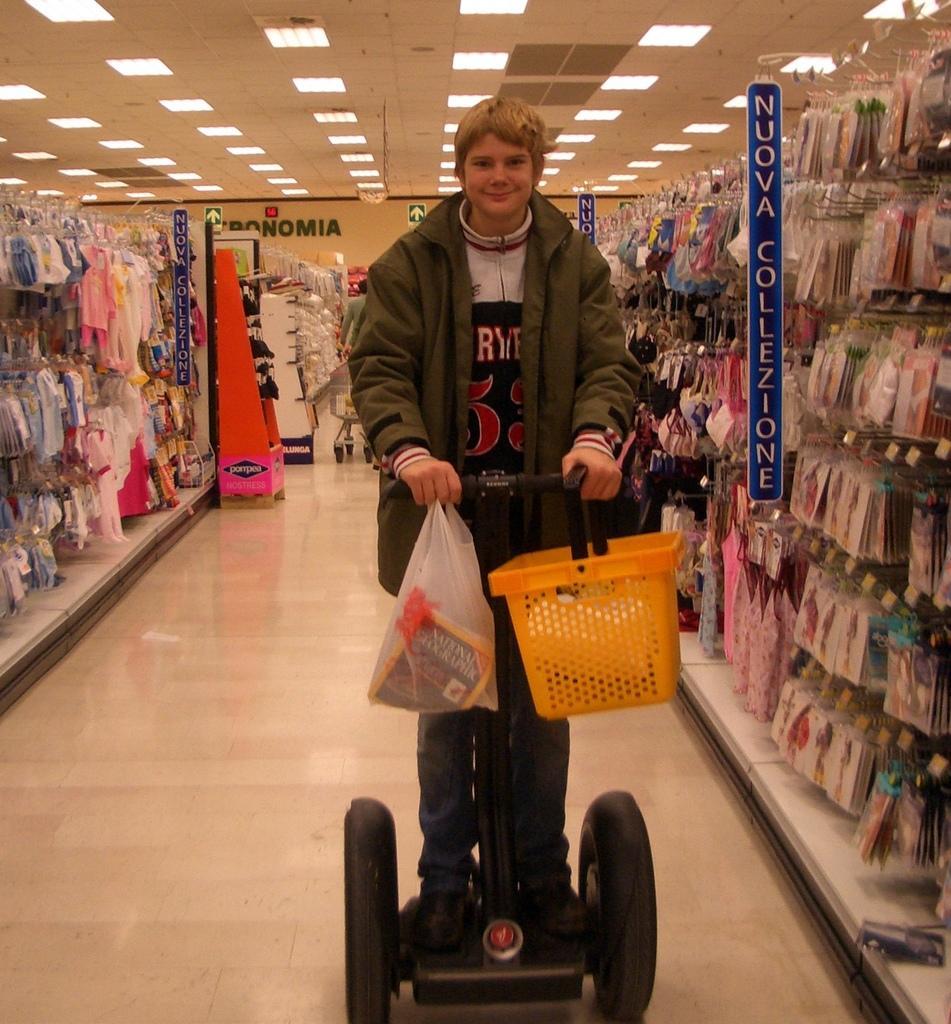How would you summarize this image in a sentence or two? In the center of the image we can see a person standing and holding baskets. On the right and left side of the image we can see objects arranged in shelves. In the background we can see wall and text. At the top of the image there are lights. 